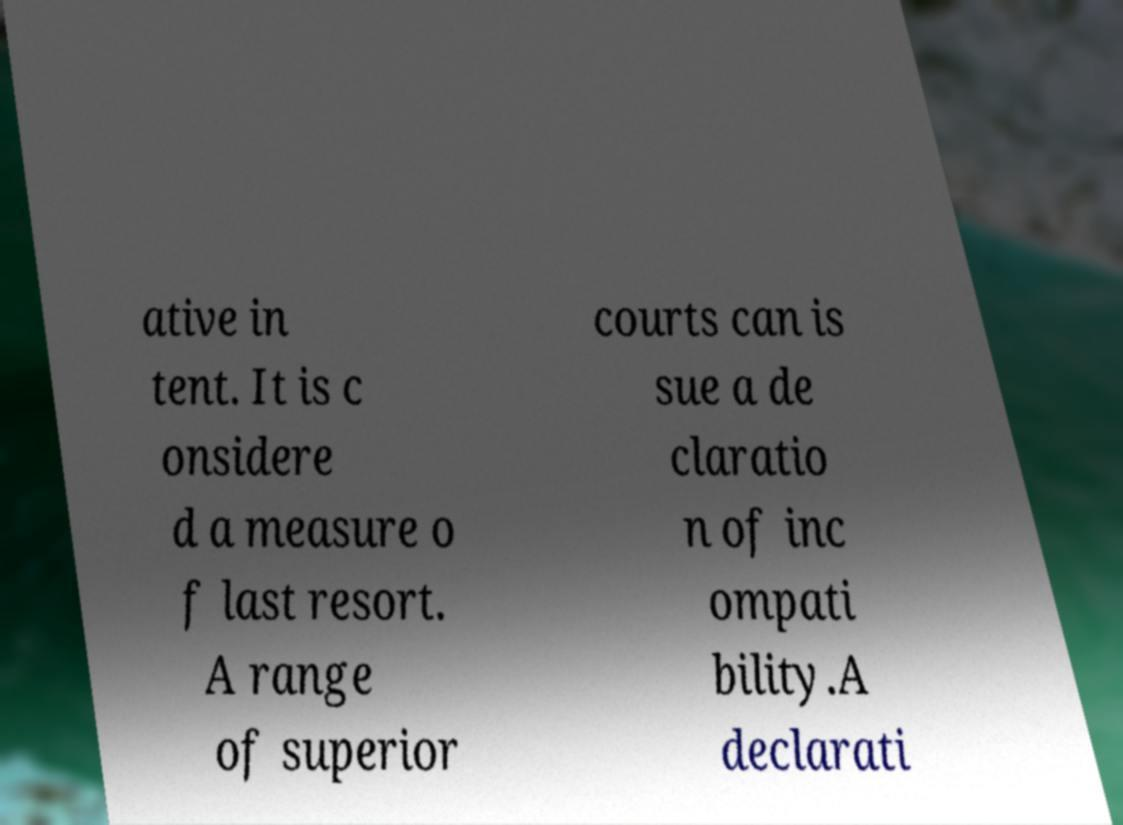Could you assist in decoding the text presented in this image and type it out clearly? ative in tent. It is c onsidere d a measure o f last resort. A range of superior courts can is sue a de claratio n of inc ompati bility.A declarati 